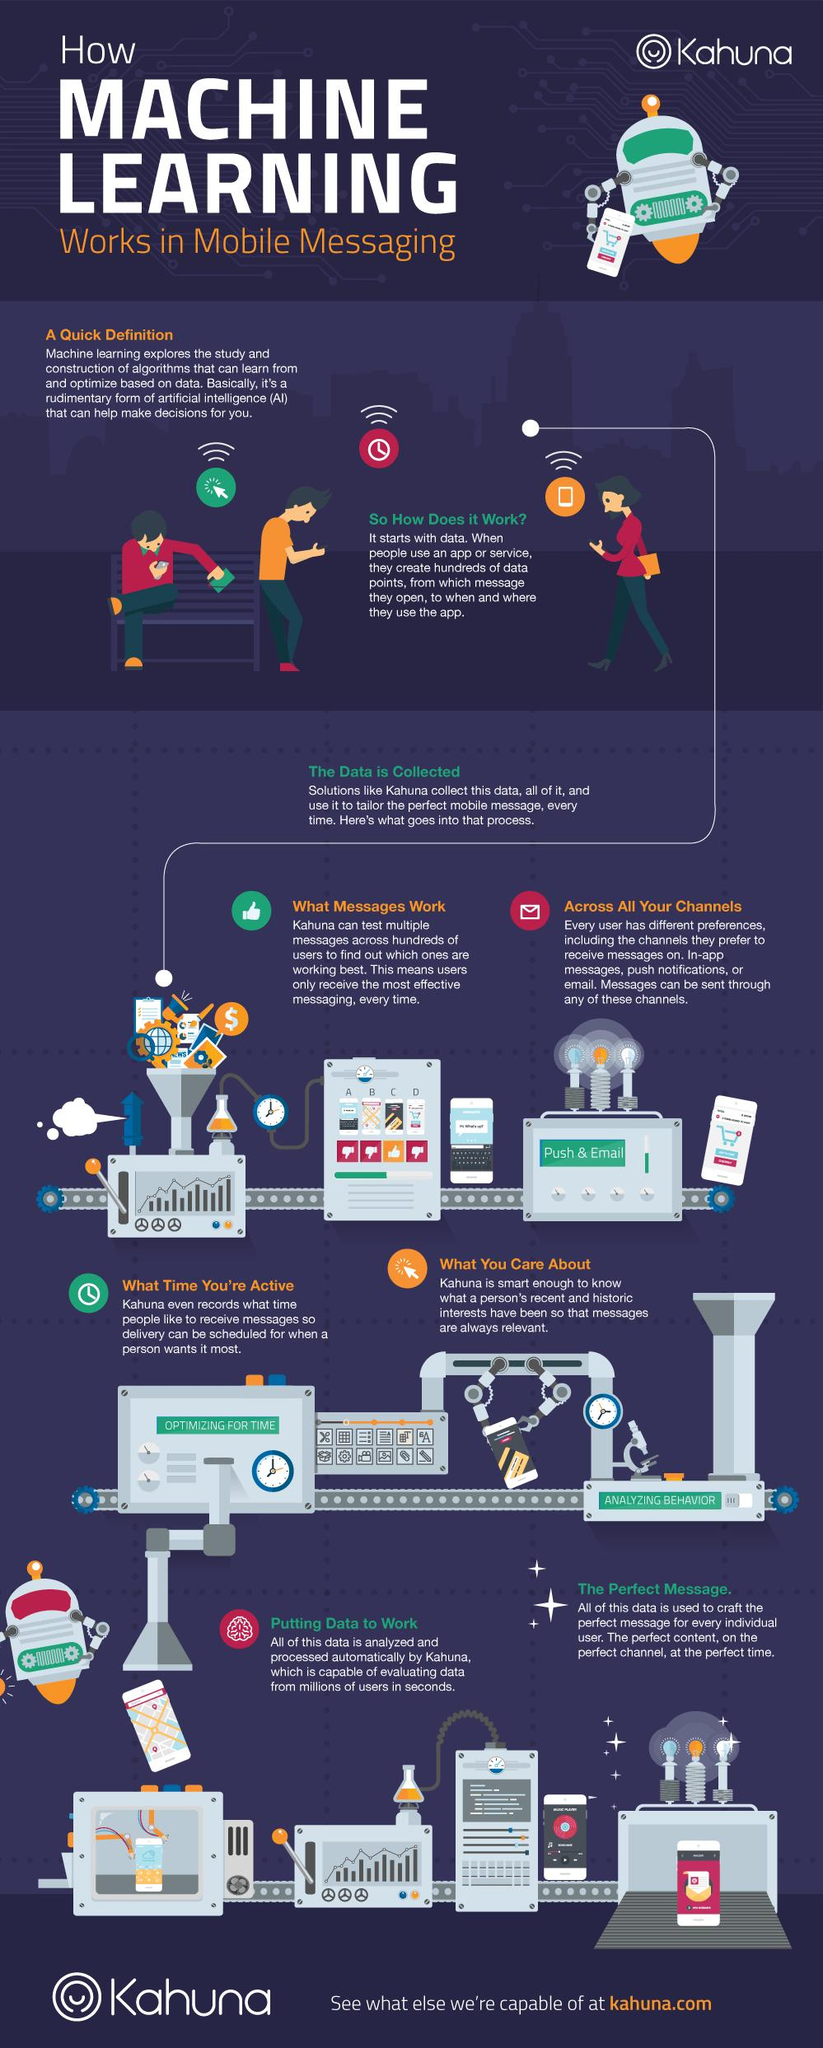Identify some key points in this picture. The exact number of steps involved in Kahuna's messaging process is six. 